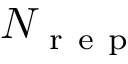<formula> <loc_0><loc_0><loc_500><loc_500>N _ { r e p }</formula> 